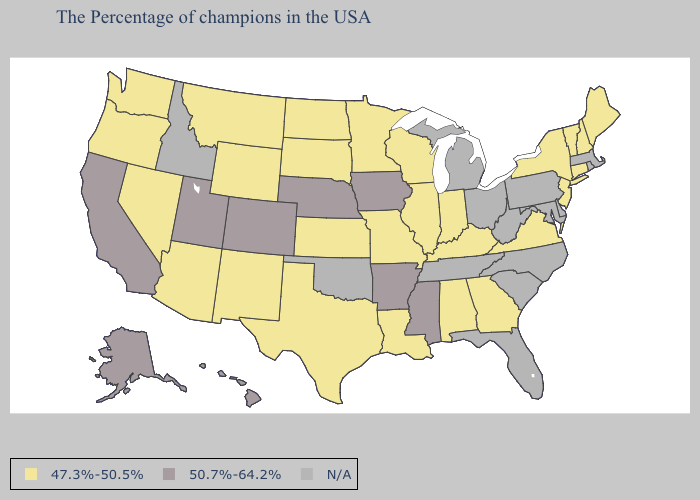What is the lowest value in the West?
Answer briefly. 47.3%-50.5%. Does Mississippi have the lowest value in the USA?
Answer briefly. No. Name the states that have a value in the range 50.7%-64.2%?
Write a very short answer. Mississippi, Arkansas, Iowa, Nebraska, Colorado, Utah, California, Alaska, Hawaii. What is the highest value in states that border Missouri?
Give a very brief answer. 50.7%-64.2%. Which states have the highest value in the USA?
Concise answer only. Mississippi, Arkansas, Iowa, Nebraska, Colorado, Utah, California, Alaska, Hawaii. How many symbols are there in the legend?
Quick response, please. 3. What is the value of Ohio?
Write a very short answer. N/A. What is the value of North Dakota?
Short answer required. 47.3%-50.5%. What is the value of New Jersey?
Answer briefly. 47.3%-50.5%. What is the lowest value in the USA?
Answer briefly. 47.3%-50.5%. Name the states that have a value in the range 50.7%-64.2%?
Keep it brief. Mississippi, Arkansas, Iowa, Nebraska, Colorado, Utah, California, Alaska, Hawaii. What is the lowest value in states that border Mississippi?
Give a very brief answer. 47.3%-50.5%. Among the states that border Iowa , does South Dakota have the lowest value?
Write a very short answer. Yes. 